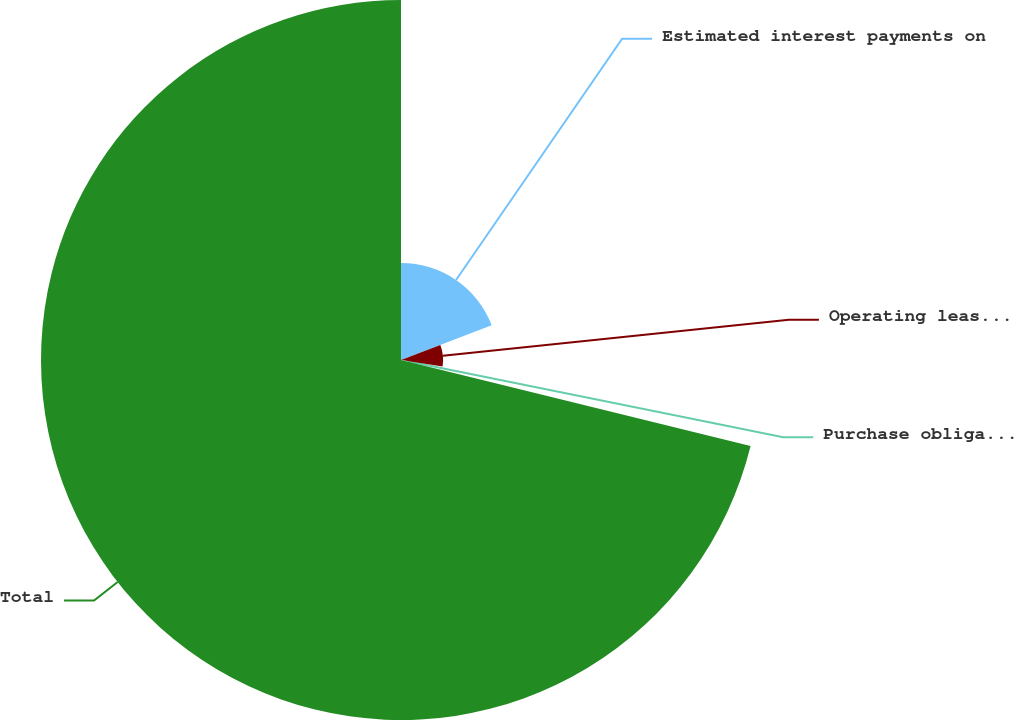Convert chart to OTSL. <chart><loc_0><loc_0><loc_500><loc_500><pie_chart><fcel>Estimated interest payments on<fcel>Operating leases (2)<fcel>Purchase obligations (3)<fcel>Total<nl><fcel>19.19%<fcel>8.32%<fcel>1.33%<fcel>71.16%<nl></chart> 